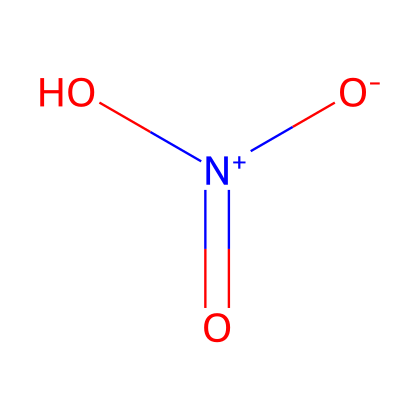How many oxygen atoms are in nitric acid? The SMILES representation shows three 'O' symbols, indicating the presence of three oxygen atoms in the molecule.
Answer: three What is the total number of atoms in nitric acid? The SMILES shows three oxygen atoms, one nitrogen atom, and one hydrogen atom. Adding these gives a total of five atoms.
Answer: five What oxidation state is nitrogen in nitric acid? The SMILES representation shows a nitrogen atom that is positively charged ('[N+]'), indicating an oxidation state of +5.
Answer: +5 What type of bond connects the nitrogen and oxygen in nitric acid? The nitrogen is connected to one oxygen by a double bond (indicated by '=') and to another oxygen by a single bond. Therefore, there is a double bond.
Answer: double bond Is nitric acid a strong oxidizer? Nitric acid is well-known to act as a powerful oxidizing agent due to its ability to donate oxygen and accept electrons.
Answer: yes How many resonance structures can be drawn for nitric acid? Nitric acid can exhibit multiple resonance structures, typically three, due to the different placements of double bonds among oxygen atoms.
Answer: three What functional group is present in nitric acid? The presence of the hydroxyl group 'O' attached to the nitrogen atom indicates that it contains a hydroxyl functional group, which is characteristic of acids.
Answer: hydroxyl 